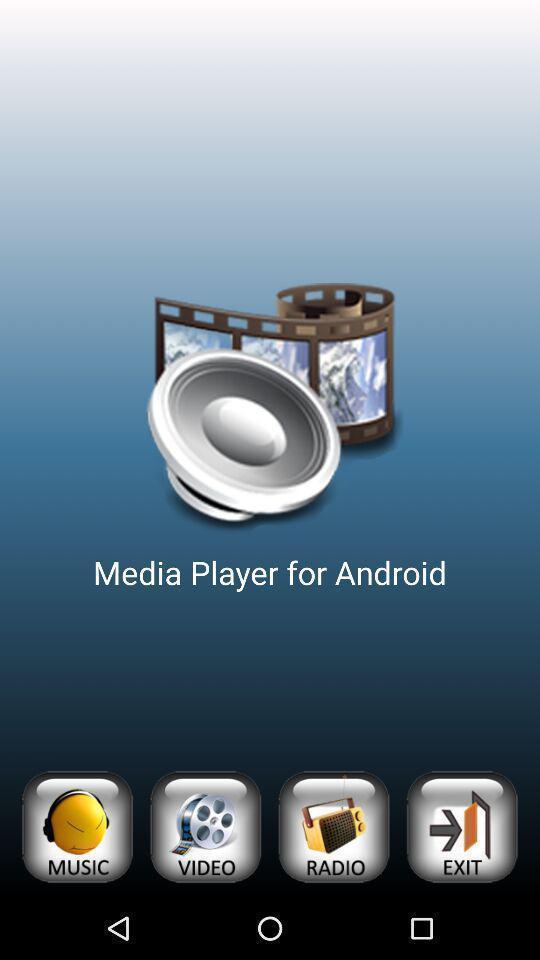Describe the visual elements of this screenshot. Screen showing page. 